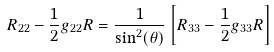<formula> <loc_0><loc_0><loc_500><loc_500>R _ { 2 2 } - \frac { 1 } { 2 } g _ { 2 2 } R = \frac { 1 } { \sin ^ { 2 } ( \theta ) } \left [ R _ { 3 3 } - \frac { 1 } { 2 } g _ { 3 3 } R \right ]</formula> 